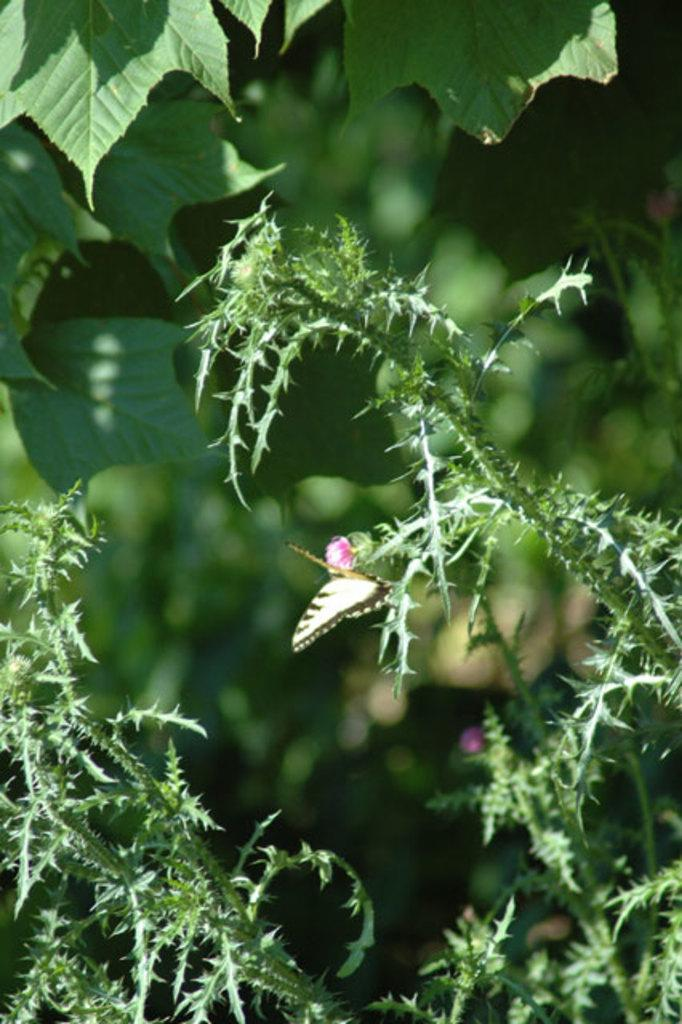What is the main subject of the image? There is a butterfly in the image. Where is the butterfly located? The butterfly is on a plant. What can be seen in the background of the image? There are plants in the background of the image. What type of screw is being used by the father to balance the butterfly in the image? There is no screw, father, or balance present in the image. 